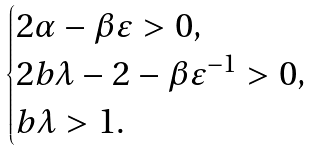<formula> <loc_0><loc_0><loc_500><loc_500>\begin{cases} 2 \alpha - \beta \varepsilon > 0 , \\ 2 b \lambda - 2 - \beta \varepsilon ^ { - 1 } > 0 , \\ b \lambda > 1 . \end{cases}</formula> 